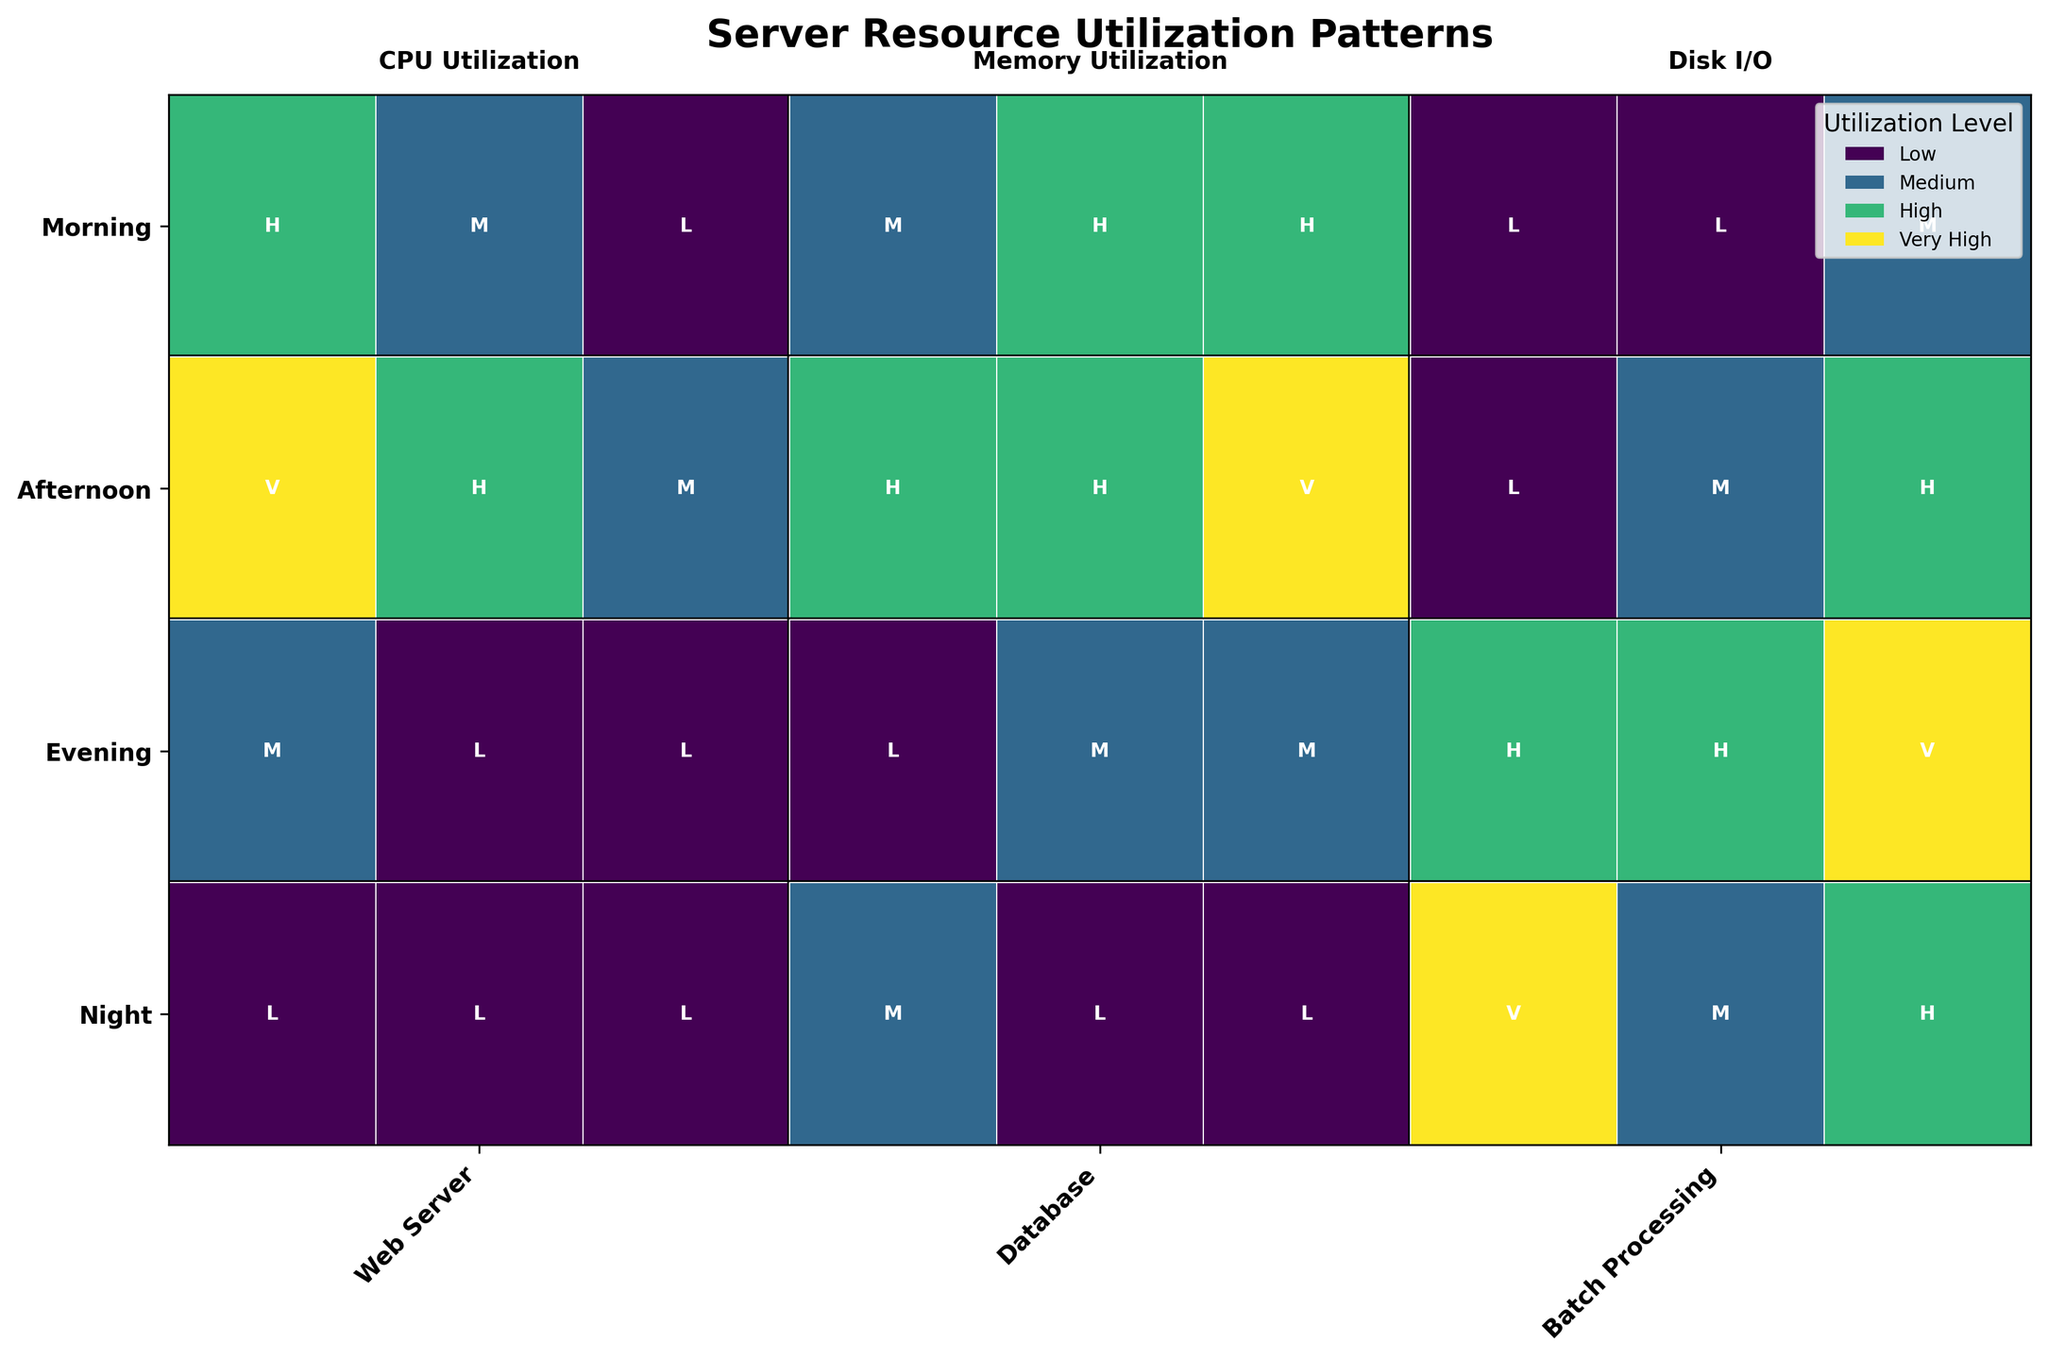What time of day has the lowest CPU utilization for the Web Server? Look for the Web Server in each time period and examine the CPU utilization levels. The CPU utilization in the night time for the Web Server is Low, which is the lowest category.
Answer: Night Which process has the highest memory utilization in the morning? Check the memory utilization levels for each process in the morning. The Database process has a High memory utilization in the morning.
Answer: Database How does the memory utilization of Batch Processing compare between the afternoon and the night? Compare the memory utilization levels for Batch Processing in the afternoon and the night. The memory utilization is Medium in the afternoon and Medium in the night.
Answer: Equal What's the difference in Disk I/O utilization between the Database process in the afternoon and the evening? Identify the Disk I/O utilization for the Database process in the afternoon and the evening. The afternoon level is Very High and the evening level is Medium. Calculate the difference: Very High (3) - Medium (1) = 2 levels.
Answer: 2 levels What time of day shows Very High resource utilization across all metrics for any process? Look for any time period where a process shows Very High utilization in CPU, Memory, and Disk I/O. Batch Processing in the night shows Very High for both CPU and Disk I/O while having Medium Memory.
Answer: None Which process type has the most balanced resource utilization pattern in the evening? Examine all processes in the evening checking for patterns where resource utilization is more balanced across CPU, Memory, and Disk I/O. The most balanced pattern appears in the Database as it falls into Low, Medium, and Medium respectively.
Answer: Database What process in the afternoon has the least balanced CPU utilization compared to other resources? Look for a process with significant deviation in CPU utilization compared to Memory and Disk I/O in the afternoon. The Web Server in the afternoon has Very High CPU, High Memory, and Medium Disk I/O, which shows the greatest imbalance.
Answer: Web Server 